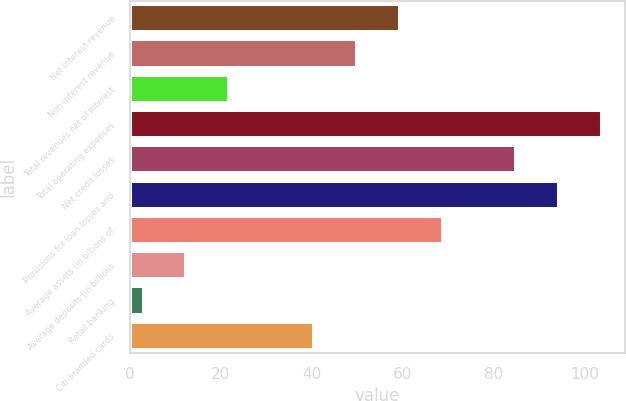<chart> <loc_0><loc_0><loc_500><loc_500><bar_chart><fcel>Net interest revenue<fcel>Non-interest revenue<fcel>Total revenues net of interest<fcel>Total operating expenses<fcel>Net credit losses<fcel>Provisions for loan losses and<fcel>Average assets (in billions of<fcel>Average deposits (in billions<fcel>Retail banking<fcel>Citi-branded cards<nl><fcel>59.4<fcel>50<fcel>21.8<fcel>103.8<fcel>85<fcel>94.4<fcel>68.8<fcel>12.4<fcel>3<fcel>40.6<nl></chart> 